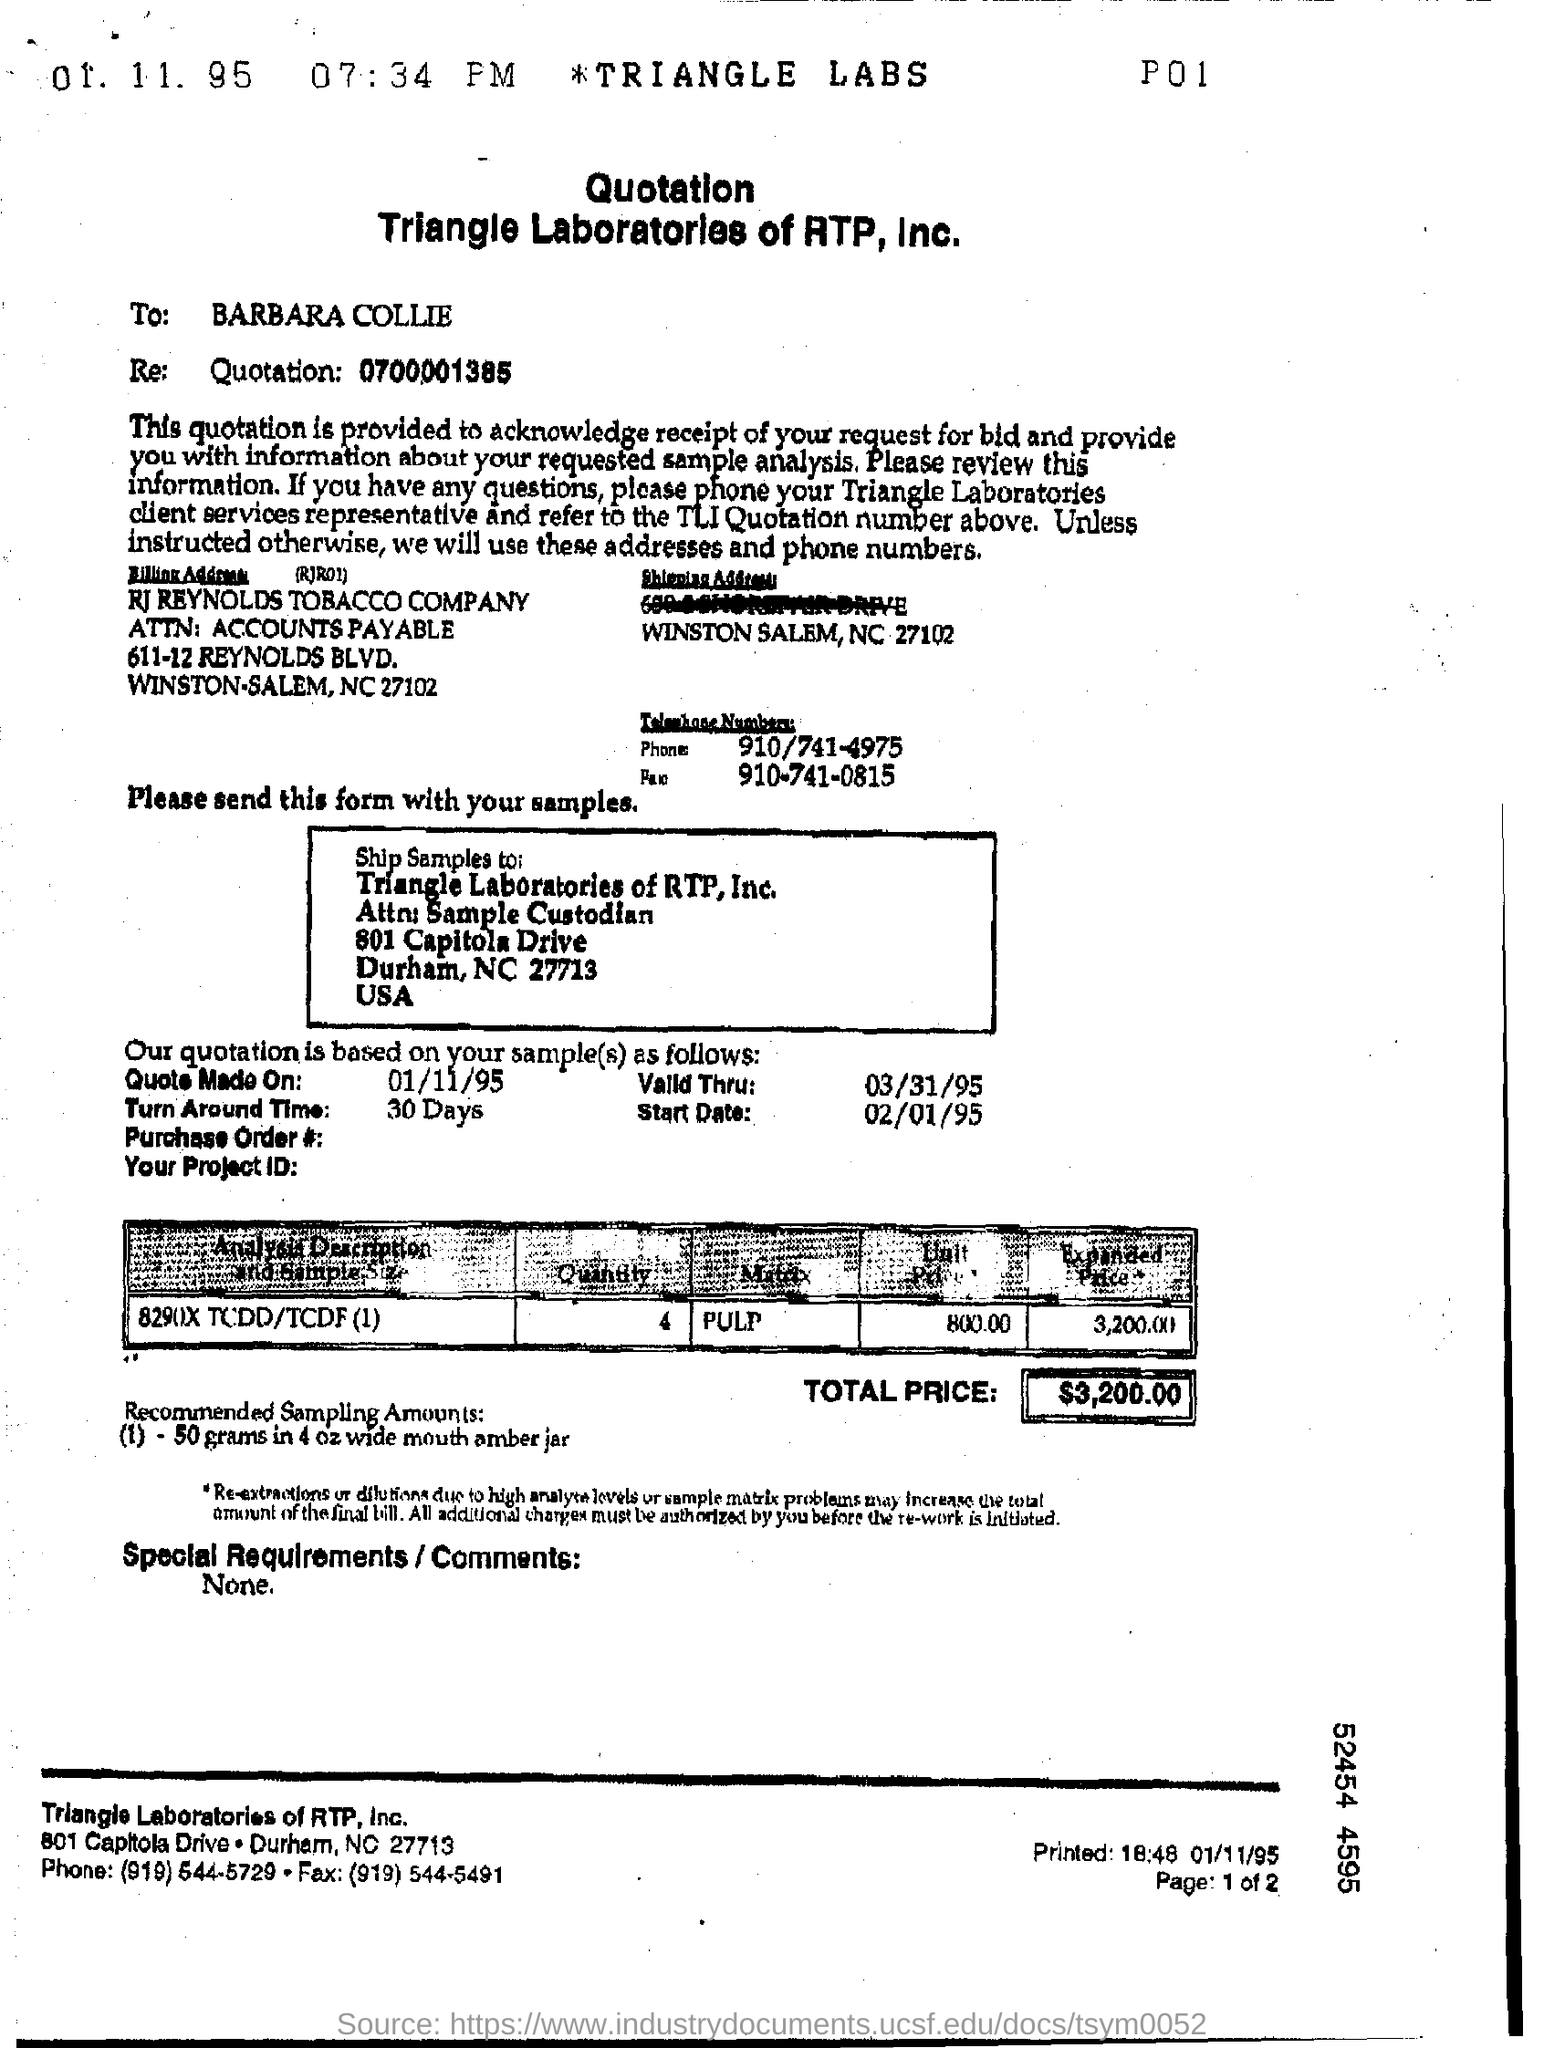Identify some key points in this picture. The unit price mentioned in the quotation is 800.00. The samples are sent to Triangle Laboratories of RTP, Inc. The person to whom this quotation is addressed is Barbara Collie. The phone number mentioned in the quotation is 910/741-4975. The turnaround time mentioned in the quotation is 30 days. 